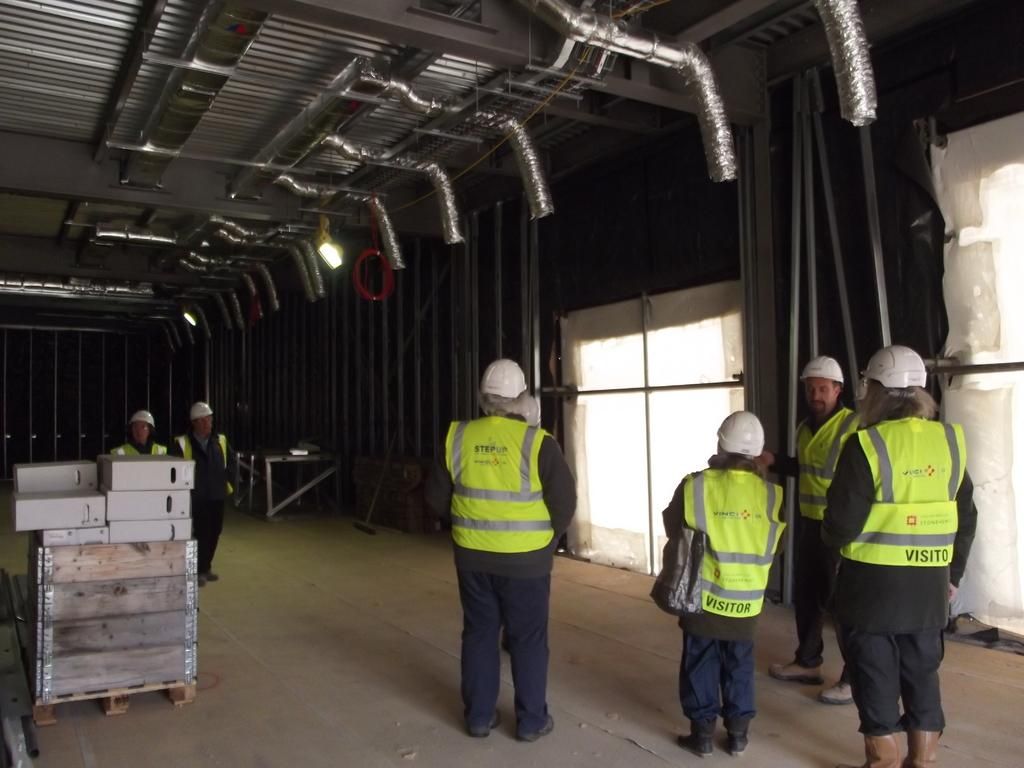How many people are in the group that is visible in the image? There is a group of people standing in the image, but the exact number cannot be determined from the provided facts. What type of objects can be seen in addition to the people? There are boxes, poles, lights, and tables in the image. What might the poles be used for in the image? The poles might be used for supporting lights or other objects in the image. What other objects can be seen in the image? There are some other objects in the image, but their specific nature cannot be determined from the provided facts. What type of music is being played by the industry in the image? There is no industry or music present in the image; it features a group of people and various objects. 